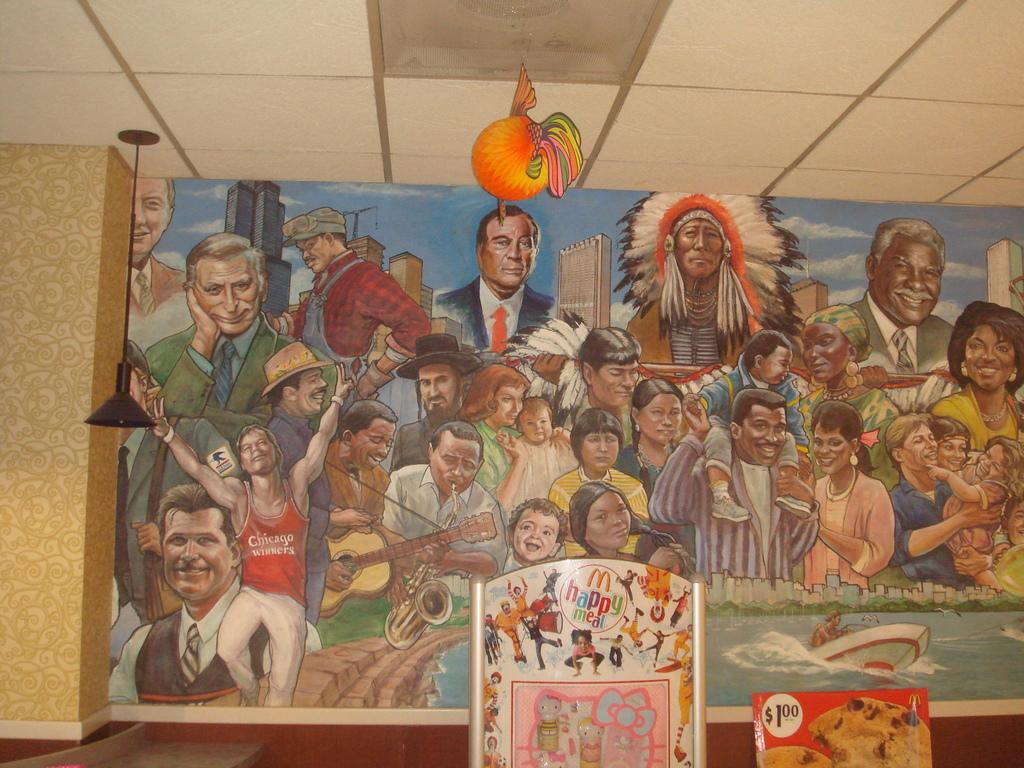What is featured in the paintings in the image? The paintings depict a group of people, buildings, water, and a boat. Can you describe the subjects of the paintings in more detail? The paintings depict a group of people, buildings, water, and a boat. What type of environment is depicted in the paintings? The paintings depict an environment that includes water and a boat, suggesting a waterfront or maritime setting. What type of tax is being discussed in the paintings? There is no mention of tax in the paintings; they depict a group of people, buildings, water, and a boat. Can you see any writing on the paintings? There is no writing visible on the paintings in the image. 